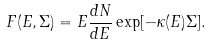<formula> <loc_0><loc_0><loc_500><loc_500>F ( E , \Sigma ) = E \frac { d N } { d E } \exp [ - \kappa ( E ) \Sigma ] .</formula> 